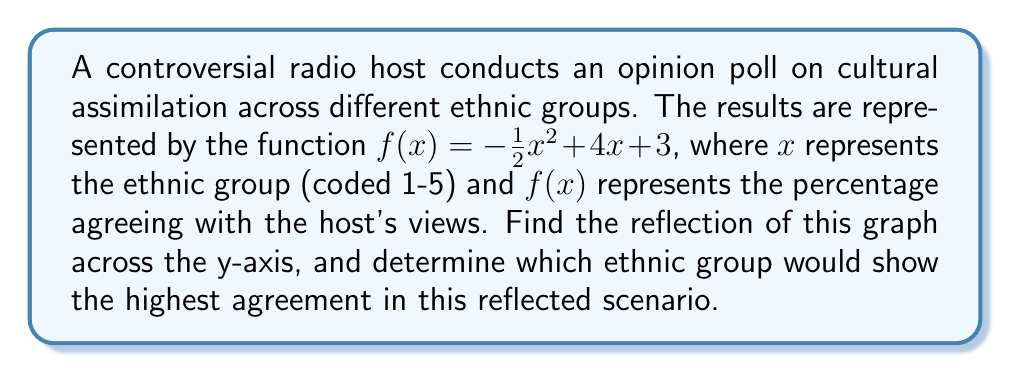Provide a solution to this math problem. To reflect the graph across the y-axis, we need to replace every $x$ with $-x$ in the original function. This gives us:

$$g(x) = -\frac{1}{2}(-x)^2 + 4(-x) + 3$$

Simplifying:
$$g(x) = -\frac{1}{2}x^2 - 4x + 3$$

This is our new function representing the reflection.

To find the ethnic group with the highest agreement, we need to find the maximum value of $g(x)$ for integer values of $x$ between 1 and 5 (as these represent our ethnic groups).

We can do this by evaluating $g(x)$ for each integer:

$g(1) = -\frac{1}{2}(1)^2 - 4(1) + 3 = -1.5$
$g(2) = -\frac{1}{2}(2)^2 - 4(2) + 3 = -7$
$g(3) = -\frac{1}{2}(3)^2 - 4(3) + 3 = -14.5$
$g(4) = -\frac{1}{2}(4)^2 - 4(4) + 3 = -24$
$g(5) = -\frac{1}{2}(5)^2 - 4(5) + 3 = -35.5$

The highest value is at $x = 1$, corresponding to ethnic group 1.
Answer: The reflection of the graph across the y-axis is given by $g(x) = -\frac{1}{2}x^2 - 4x + 3$. In this reflected scenario, ethnic group 1 would show the highest agreement with the host's views. 